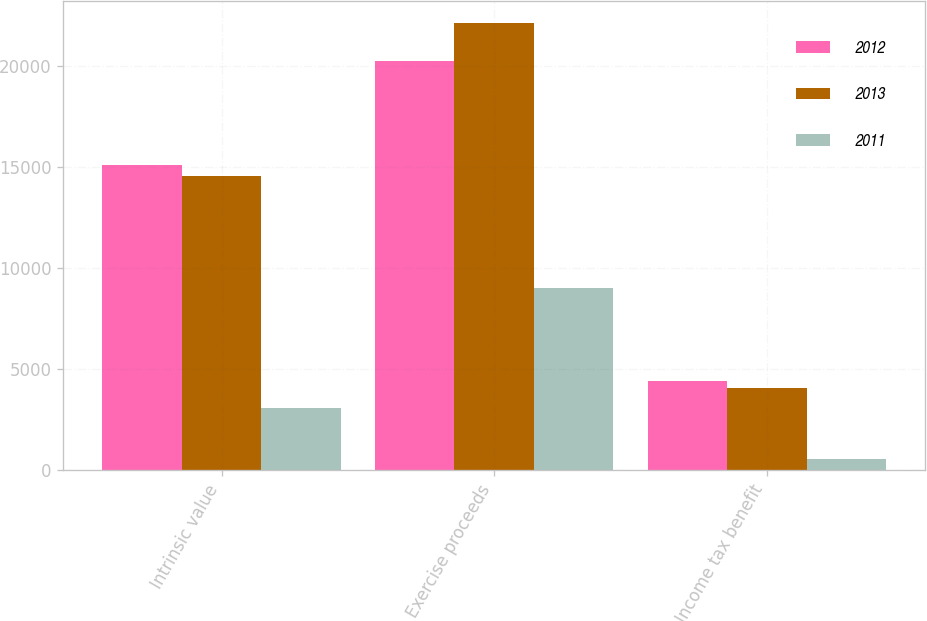Convert chart. <chart><loc_0><loc_0><loc_500><loc_500><stacked_bar_chart><ecel><fcel>Intrinsic value<fcel>Exercise proceeds<fcel>Income tax benefit<nl><fcel>2012<fcel>15102<fcel>20211<fcel>4383<nl><fcel>2013<fcel>14515<fcel>22112<fcel>4017<nl><fcel>2011<fcel>3026<fcel>8991<fcel>511<nl></chart> 